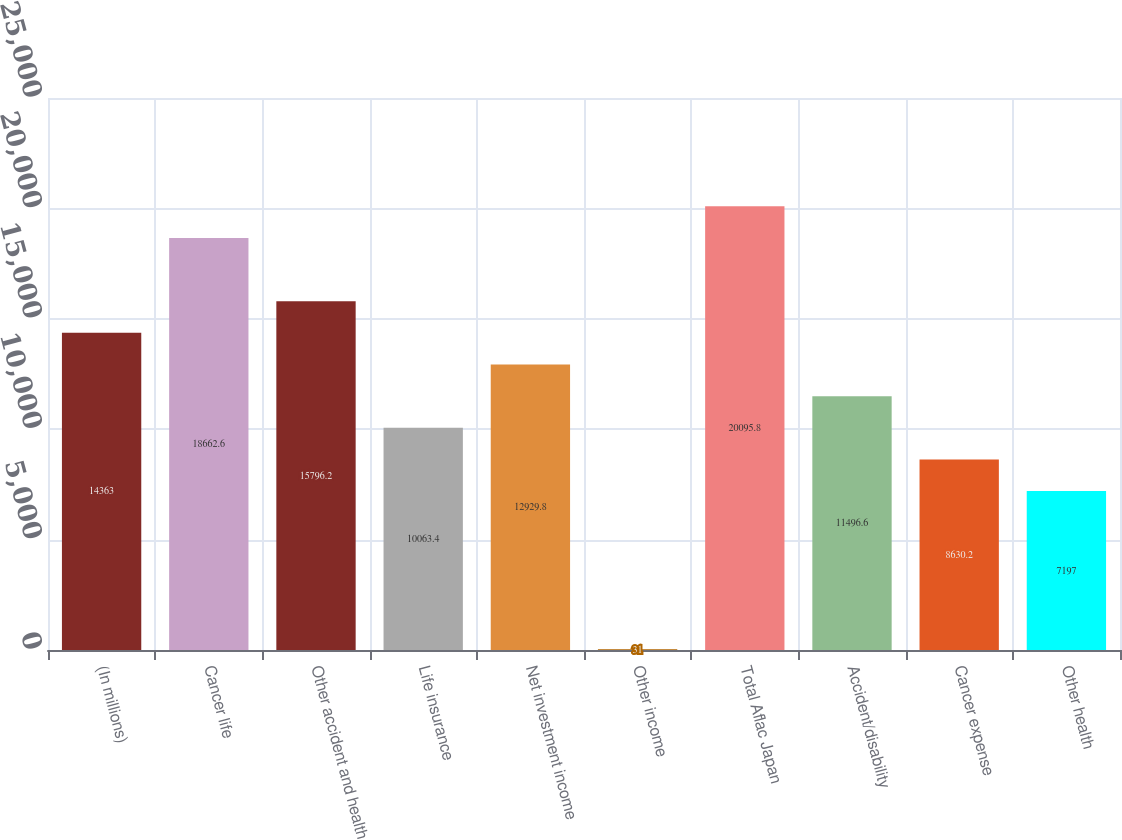<chart> <loc_0><loc_0><loc_500><loc_500><bar_chart><fcel>(In millions)<fcel>Cancer life<fcel>Other accident and health<fcel>Life insurance<fcel>Net investment income<fcel>Other income<fcel>Total Aflac Japan<fcel>Accident/disability<fcel>Cancer expense<fcel>Other health<nl><fcel>14363<fcel>18662.6<fcel>15796.2<fcel>10063.4<fcel>12929.8<fcel>31<fcel>20095.8<fcel>11496.6<fcel>8630.2<fcel>7197<nl></chart> 